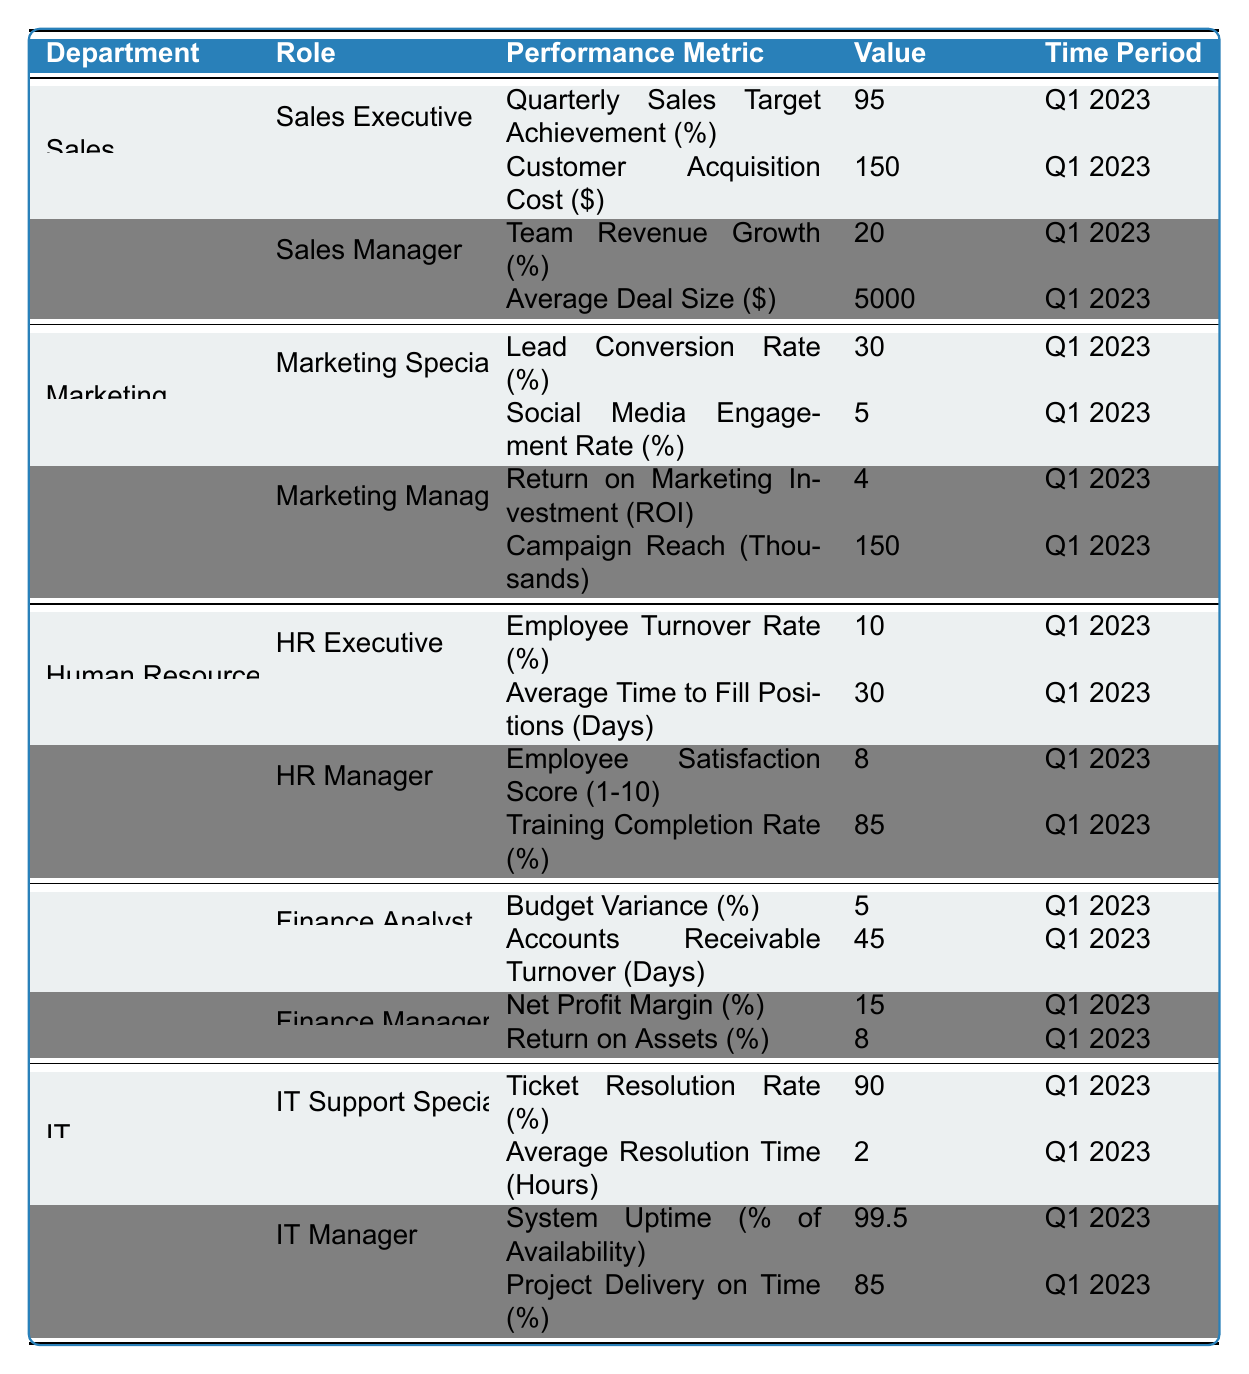What is the value of the Quarterly Sales Target Achievement for Sales Executives? The table shows the performance metric for Sales Executives in the Sales department. For the metric "Quarterly Sales Target Achievement (%)," the value is directly provided as 95 in Q1 2023.
Answer: 95 What role in the Marketing department has the highest Return on Marketing Investment? The table indicates that the Marketing Manager has a Return on Marketing Investment (ROI) of 4, while the Marketing Specialist does not have this metric listed. Thus, the Marketing Manager holds the highest ROI as it’s the only one provided for the department.
Answer: Marketing Manager How much is the Customer Acquisition Cost for Sales Executives? By reviewing the table, the Performance Metric "Customer Acquisition Cost ($)" for the Sales Executives in the Sales department shows a value of 150 for Q1 2023.
Answer: 150 What is the average Training Completion Rate for HR roles? There are two HR roles listed: HR Executive (85%) and HR Manager (Training Completion Rate 85%). To find the average, (85 + 85) / 2 = 85.
Answer: 85 Is the Employee Turnover Rate for HR Executives above or below 10%? The table lists the Employee Turnover Rate (%) for HR Executives as 10%. Since it is exactly 10%, it is neither above nor below.
Answer: No Which department has the highest average score for performance metrics in Q1 2023? To identify the department with the highest average performance metric score, we analyze the data. Sales Executive has an average score of (95 + 150) / 2 = 122.5, Marketing Manager has an average of (4 + 150) / 2 = 77. For HR, the average is (10 + 30 + 8 + 85) / 4 = 33.25. Finance's average is (5 + 45 + 15 + 8) / 4 = 18.5, while IT Managers average (99.5 + 85) / 2 = 92.75. Ultimately, the Sales department has the highest average.
Answer: Sales What is the difference in the Net Profit Margin and Return on Assets for Finance Managers? For Finance Managers, the Net Profit Margin is 15% and Return on Assets is 8%. The difference is calculated as 15 - 8 = 7.
Answer: 7 What percentage of Employee Satisfaction Score is reported for HR Managers? Looking at the table, the Employee Satisfaction Score (1-10) for HR Managers is specified as 8.
Answer: 8 How many performance metrics for IT Support Specialists are reported in the table? The table indicates that there are two performance metrics for IT Support Specialists: Ticket Resolution Rate (%) and Average Resolution Time (Hours). Therefore, the total count is 2.
Answer: 2 Was the average Resolution Time for IT Support Specialists above 3 hours? The table shows that the Average Resolution Time (Hours) for IT Support Specialists is 2. Since 2 is below 3, the answer is no.
Answer: No What is the Team Revenue Growth percentage for Sales Managers? According to the table, the Team Revenue Growth (%) for Sales Managers in the Sales department is 20 in Q1 2023.
Answer: 20 